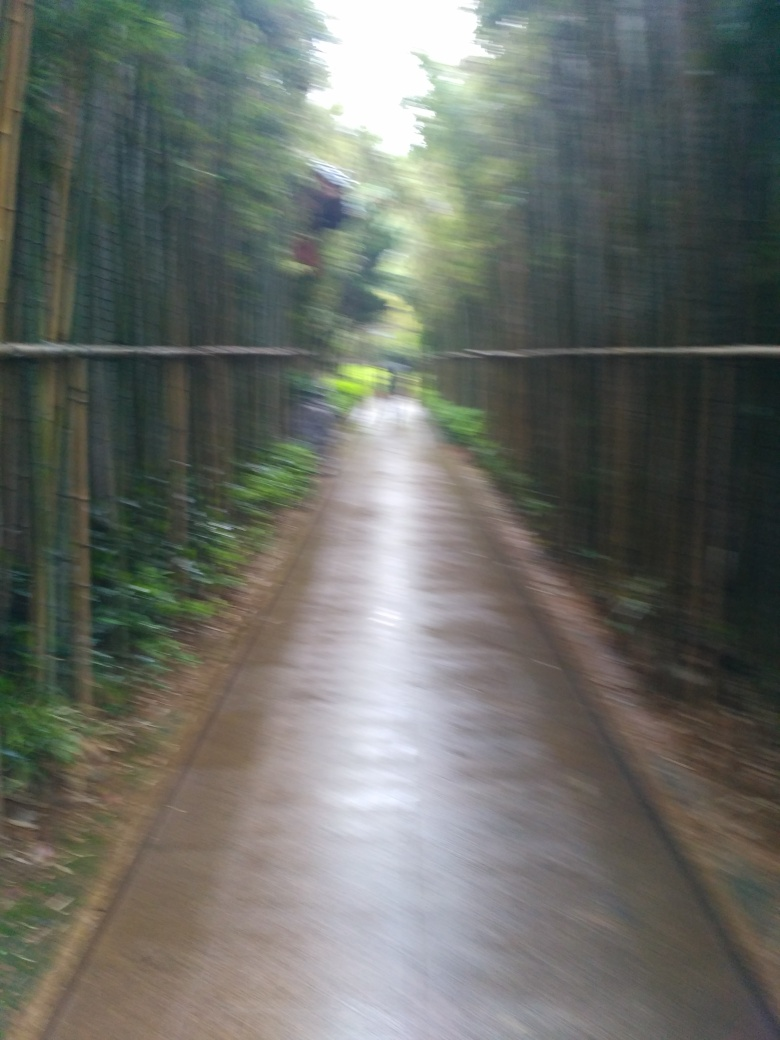What are the main subjects in the image?
A. Trees and flowers
B. Buildings and people
C. Sky and clouds
D. Road and bamboo
Answer with the option's letter from the given choices directly. Upon observing the image provided, the most prominent subjects appear to be a path surrounded by a dense growth of bamboo on either side. So the correct answer to the question is Option D: Road and bamboo. The bamboo provides a natural and serene atmosphere, implying that the photograph might have been taken in a bamboo grove or a similar tranquil environment. 